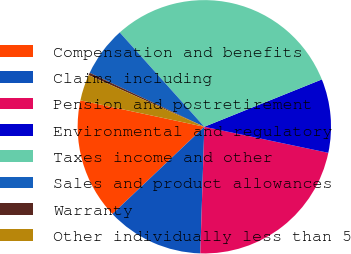<chart> <loc_0><loc_0><loc_500><loc_500><pie_chart><fcel>Compensation and benefits<fcel>Claims including<fcel>Pension and postretirement<fcel>Environmental and regulatory<fcel>Taxes income and other<fcel>Sales and product allowances<fcel>Warranty<fcel>Other individually less than 5<nl><fcel>15.43%<fcel>12.41%<fcel>22.21%<fcel>9.39%<fcel>30.54%<fcel>6.36%<fcel>0.32%<fcel>3.34%<nl></chart> 